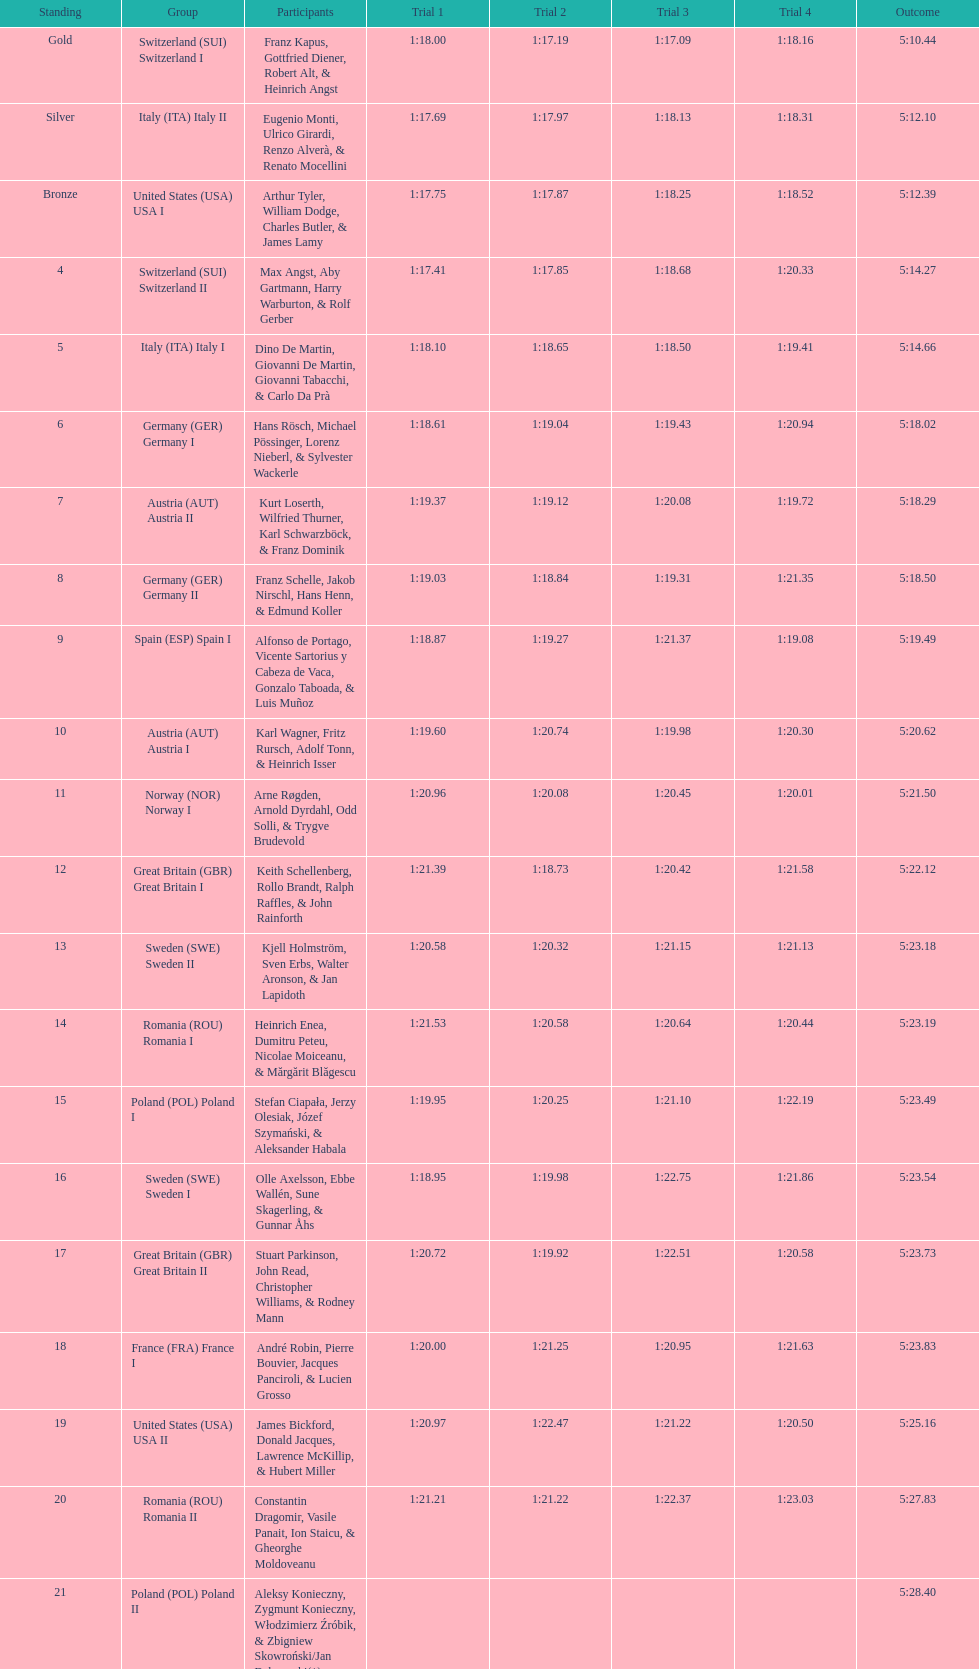How many teams did germany have? 2. 